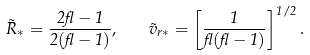<formula> <loc_0><loc_0><loc_500><loc_500>\tilde { R } _ { * } = \frac { 2 \gamma - 1 } { 2 ( \gamma - 1 ) } , \quad \tilde { v } _ { r * } = \left [ \frac { 1 } { \gamma ( \gamma - 1 ) } \right ] ^ { 1 / 2 } .</formula> 